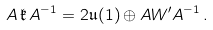Convert formula to latex. <formula><loc_0><loc_0><loc_500><loc_500>A \, \mathfrak { k } \, A ^ { - 1 } = 2 \mathfrak { u } ( 1 ) \oplus A W ^ { \prime } A ^ { - 1 } \, .</formula> 